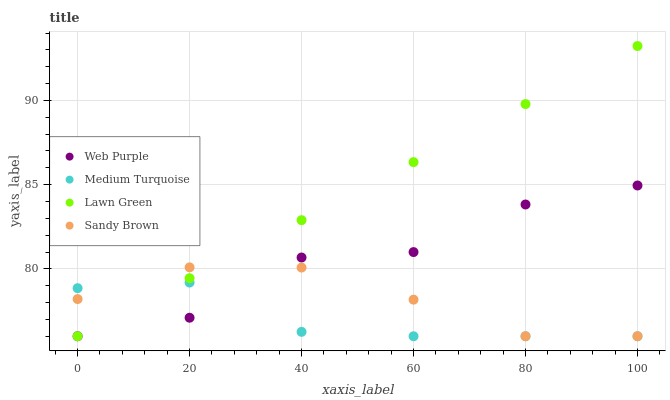Does Medium Turquoise have the minimum area under the curve?
Answer yes or no. Yes. Does Lawn Green have the maximum area under the curve?
Answer yes or no. Yes. Does Web Purple have the minimum area under the curve?
Answer yes or no. No. Does Web Purple have the maximum area under the curve?
Answer yes or no. No. Is Lawn Green the smoothest?
Answer yes or no. Yes. Is Web Purple the roughest?
Answer yes or no. Yes. Is Sandy Brown the smoothest?
Answer yes or no. No. Is Sandy Brown the roughest?
Answer yes or no. No. Does Lawn Green have the lowest value?
Answer yes or no. Yes. Does Lawn Green have the highest value?
Answer yes or no. Yes. Does Web Purple have the highest value?
Answer yes or no. No. Does Sandy Brown intersect Web Purple?
Answer yes or no. Yes. Is Sandy Brown less than Web Purple?
Answer yes or no. No. Is Sandy Brown greater than Web Purple?
Answer yes or no. No. 